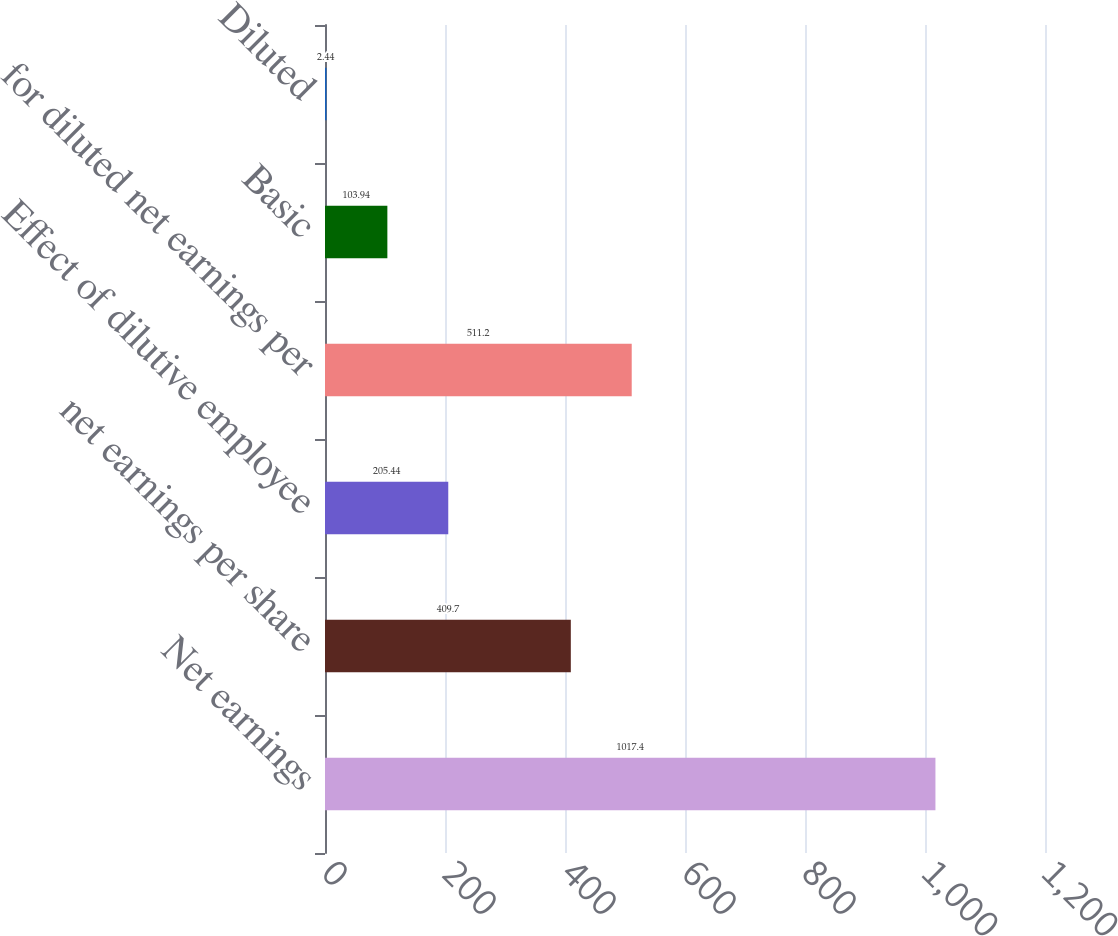Convert chart. <chart><loc_0><loc_0><loc_500><loc_500><bar_chart><fcel>Net earnings<fcel>net earnings per share<fcel>Effect of dilutive employee<fcel>for diluted net earnings per<fcel>Basic<fcel>Diluted<nl><fcel>1017.4<fcel>409.7<fcel>205.44<fcel>511.2<fcel>103.94<fcel>2.44<nl></chart> 